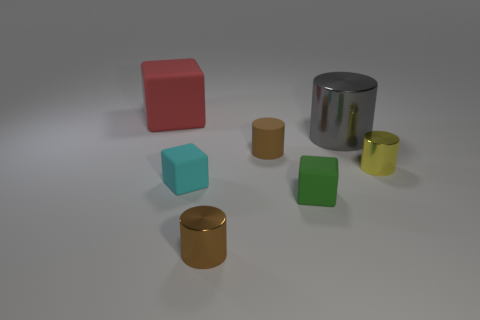Subtract 1 cylinders. How many cylinders are left? 3 Add 1 purple objects. How many objects exist? 8 Subtract all cylinders. How many objects are left? 3 Subtract all tiny red metal things. Subtract all tiny matte things. How many objects are left? 4 Add 1 small cyan matte cubes. How many small cyan matte cubes are left? 2 Add 2 yellow metallic things. How many yellow metallic things exist? 3 Subtract 0 brown spheres. How many objects are left? 7 